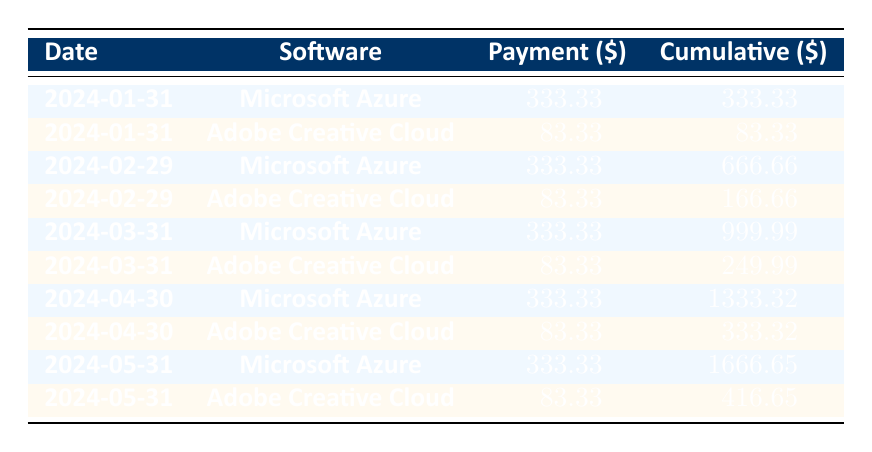What is the total cumulative payment for Microsoft Azure by December 31, 2024? The cumulative total for Microsoft Azure is indicated for each payment date. By checking the row corresponding to December 31, 2024, we see that the cumulative total is 4000.00.
Answer: 4000.00 How much was the payment made for Adobe Creative Cloud on March 31, 2025? The payment amount for Adobe Creative Cloud on March 31, 2025, is directly referenced in the table. The row for March 31, 2025, shows a payment amount of 83.33.
Answer: 83.33 Which software had a higher cumulative payment on January 31, 2025? To determine which software had a higher cumulative payment, we compare the cumulative totals for both software on January 31, 2025. Microsoft Azure had a cumulative total of 4333.33, while Adobe Creative Cloud had a cumulative total of 1083.29. Since 4333.33 is greater than 1083.29, Microsoft Azure had a higher cumulative payment.
Answer: Microsoft Azure Does Adobe Creative Cloud have the same payment amount each month? By reviewing the payment amounts for Adobe Creative Cloud across various months, it is observed that every payment is consistently listed as 83.33. Thus, it can be concluded that the payment amount does not vary.
Answer: Yes What is the total payment made for Microsoft Azure from January to March 2025? We will sum the payment amounts for Microsoft Azure from January to March 2025: 333.33 (January) + 333.33 (February) + 333.33 (March). This results in a total of 999.99.
Answer: 999.99 What is the cumulative total for both software on April 30, 2025? To answer this, we look at the cumulative totals for both Microsoft Azure and Adobe Creative Cloud on April 30, 2025. For Microsoft Azure, it is 5333.33 and for Adobe Creative Cloud, it is 1333.28. The cumulative total for both is 5333.33 + 1333.28 = 6666.61.
Answer: 6666.61 Is the payment for any software greater than 5000.00 by the end of 2025? By reviewing the cumulative payments at the end of 2025, Microsoft Azure shows a total of 8000.00 while Adobe Creative Cloud shows 3000.00. Since 8000.00 is greater than 5000.00, there is indeed at least one software with a payment greater than that amount.
Answer: Yes What is the average payment made for Adobe Creative Cloud over the entire term? To find the average payment amount, we take the total cost of 3000.00 and divide it by the term length in months (36 months). Thus, the average payment is 3000.00 / 36 = 83.33.
Answer: 83.33 